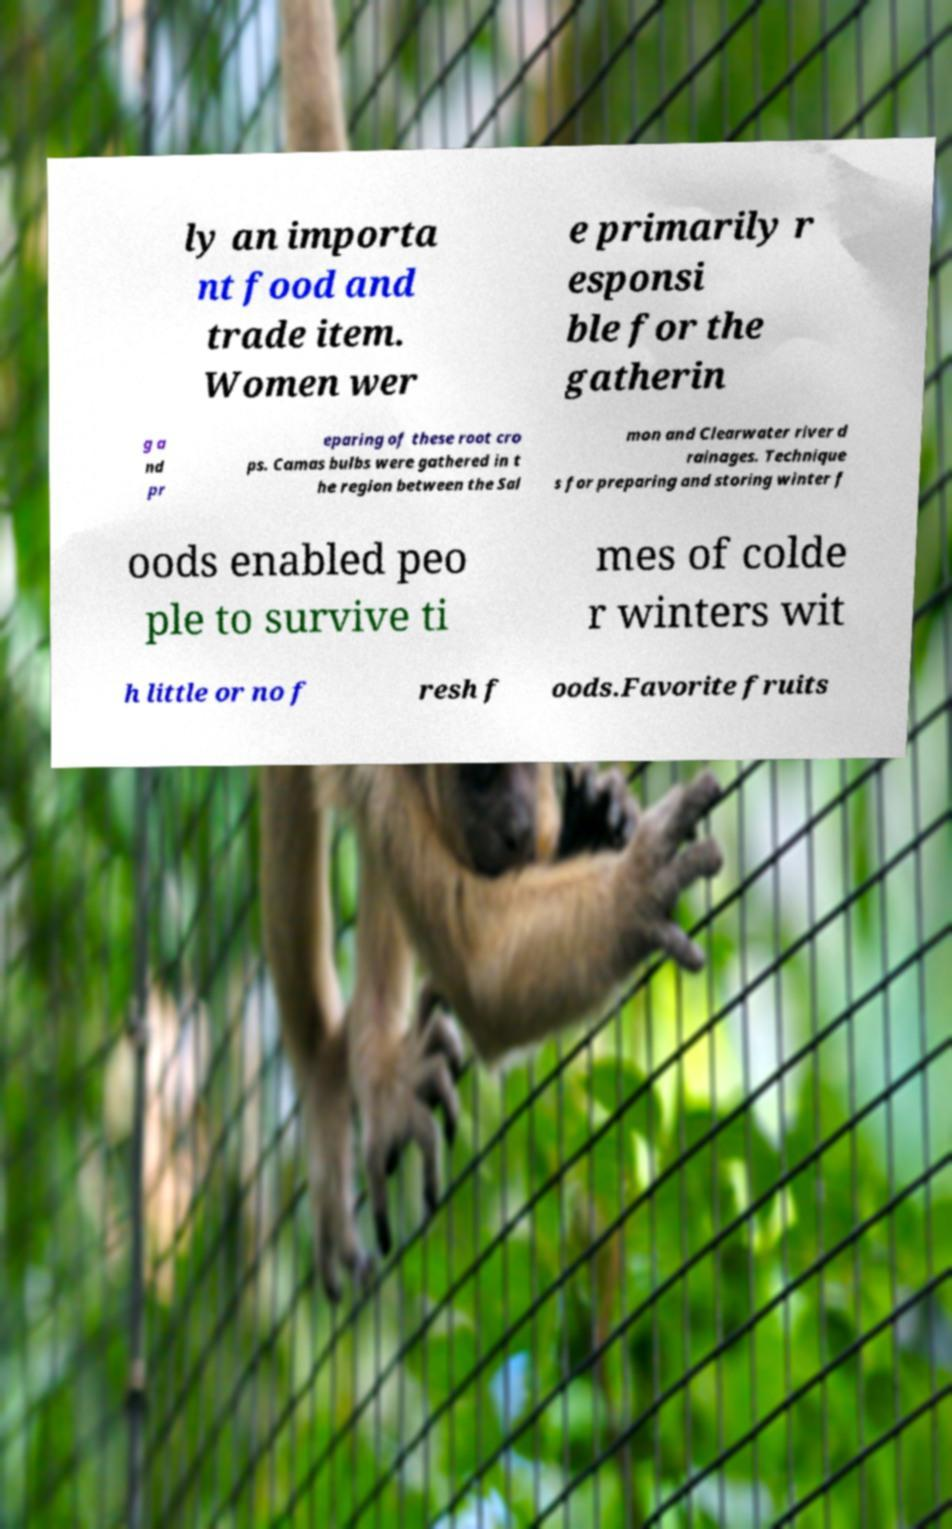I need the written content from this picture converted into text. Can you do that? ly an importa nt food and trade item. Women wer e primarily r esponsi ble for the gatherin g a nd pr eparing of these root cro ps. Camas bulbs were gathered in t he region between the Sal mon and Clearwater river d rainages. Technique s for preparing and storing winter f oods enabled peo ple to survive ti mes of colde r winters wit h little or no f resh f oods.Favorite fruits 